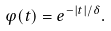Convert formula to latex. <formula><loc_0><loc_0><loc_500><loc_500>\varphi ( t ) = e ^ { - | t | / \delta } .</formula> 